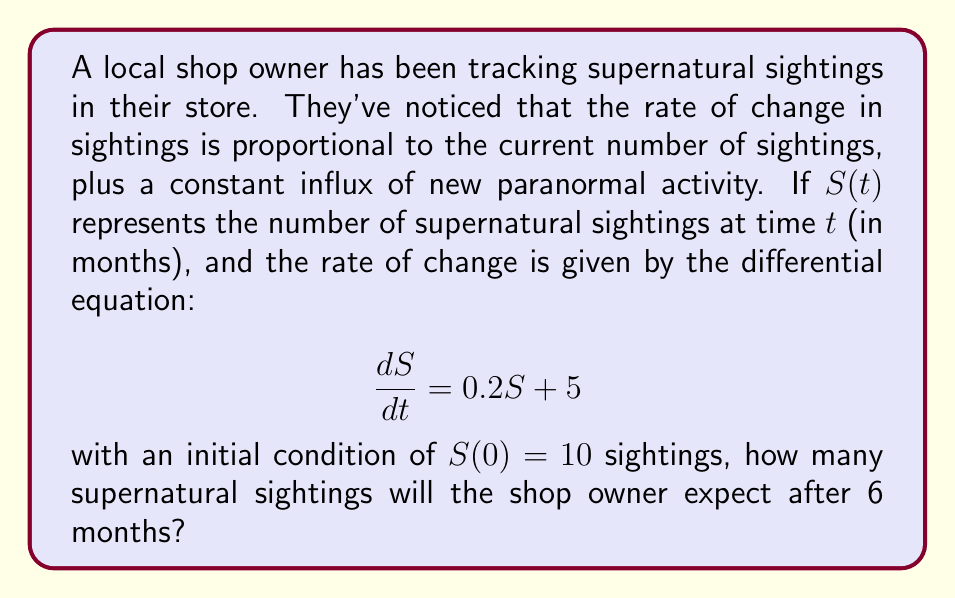Can you solve this math problem? To solve this first-order linear differential equation, we'll follow these steps:

1) The general form of this differential equation is:
   $$\frac{dS}{dt} = aS + b$$
   where $a = 0.2$ and $b = 5$

2) The solution to this type of equation is:
   $$S(t) = Ce^{at} - \frac{b}{a}$$
   where $C$ is a constant we need to determine.

3) Substituting our values:
   $$S(t) = Ce^{0.2t} - \frac{5}{0.2} = Ce^{0.2t} - 25$$

4) To find $C$, we use the initial condition $S(0) = 10$:
   $$10 = Ce^{0.2(0)} - 25$$
   $$10 = C - 25$$
   $$C = 35$$

5) Our particular solution is therefore:
   $$S(t) = 35e^{0.2t} - 25$$

6) To find the number of sightings after 6 months, we evaluate $S(6)$:
   $$S(6) = 35e^{0.2(6)} - 25$$
   $$S(6) = 35e^{1.2} - 25$$
   $$S(6) = 35(3.3201) - 25$$
   $$S(6) = 116.2035 - 25$$
   $$S(6) = 91.2035$$

7) Rounding to the nearest whole number (as we can't have partial sightings):
   $$S(6) \approx 91$$
Answer: After 6 months, the shop owner can expect approximately 91 supernatural sightings. 